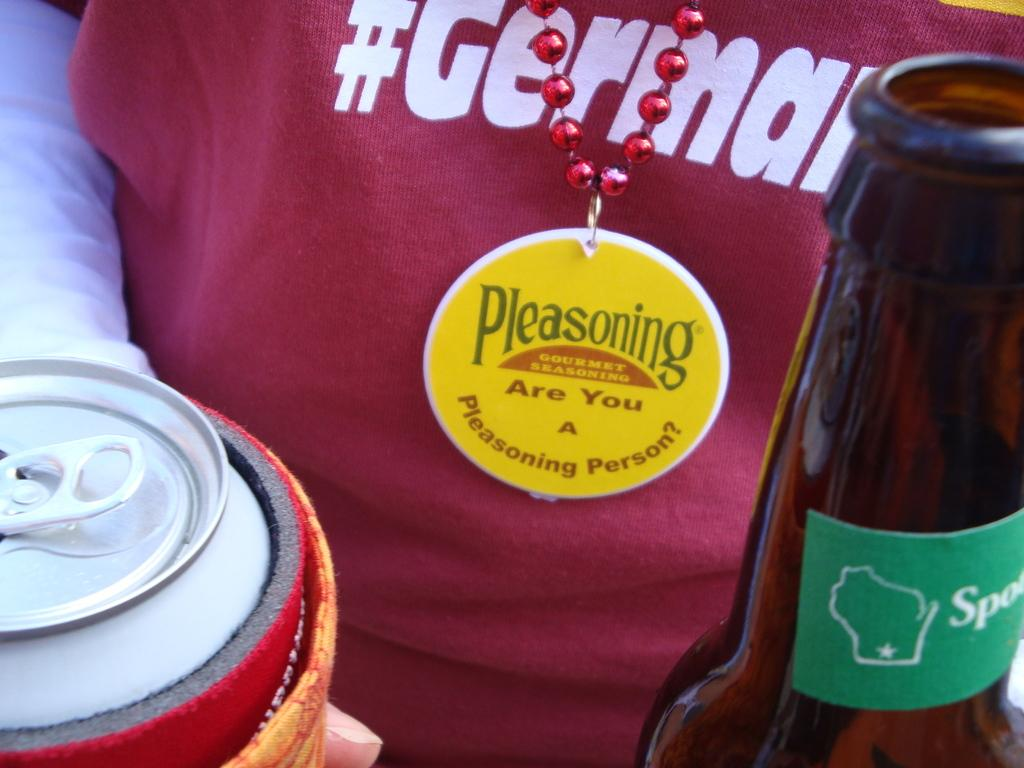What objects is the man holding in the image? The man is holding a bottle and a can in the image. Can you describe the objects the man is holding? There is a bottle and a can in the image. What type of creature is the man holding in the image? There is no creature present in the image; the man is holding a bottle and a can. 